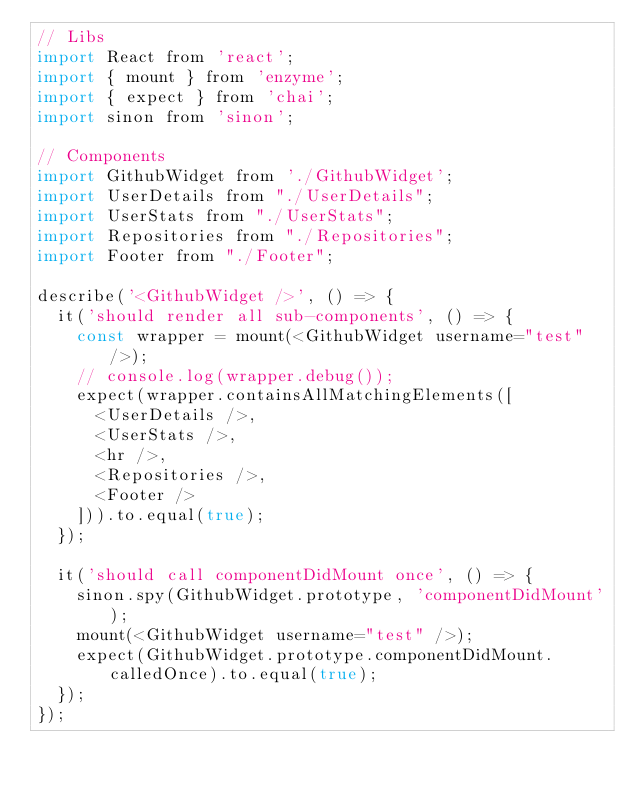Convert code to text. <code><loc_0><loc_0><loc_500><loc_500><_JavaScript_>// Libs
import React from 'react';
import { mount } from 'enzyme';
import { expect } from 'chai';
import sinon from 'sinon';

// Components
import GithubWidget from './GithubWidget';
import UserDetails from "./UserDetails";
import UserStats from "./UserStats";
import Repositories from "./Repositories";
import Footer from "./Footer";

describe('<GithubWidget />', () => {
  it('should render all sub-components', () => {
    const wrapper = mount(<GithubWidget username="test" />);
    // console.log(wrapper.debug());
    expect(wrapper.containsAllMatchingElements([
      <UserDetails />,
      <UserStats />,
      <hr />,
      <Repositories />,
      <Footer />
    ])).to.equal(true);
  });

  it('should call componentDidMount once', () => {
    sinon.spy(GithubWidget.prototype, 'componentDidMount');
    mount(<GithubWidget username="test" />);
    expect(GithubWidget.prototype.componentDidMount.calledOnce).to.equal(true);
  });
});
</code> 